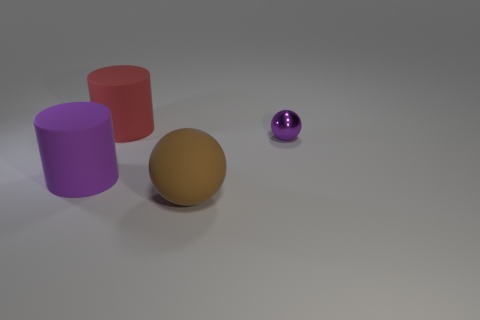Add 4 purple metallic balls. How many objects exist? 8 Add 3 metal spheres. How many metal spheres are left? 4 Add 3 large matte cylinders. How many large matte cylinders exist? 5 Subtract 1 red cylinders. How many objects are left? 3 Subtract 1 spheres. How many spheres are left? 1 Subtract all purple spheres. Subtract all gray blocks. How many spheres are left? 1 Subtract all brown spheres. Subtract all large yellow things. How many objects are left? 3 